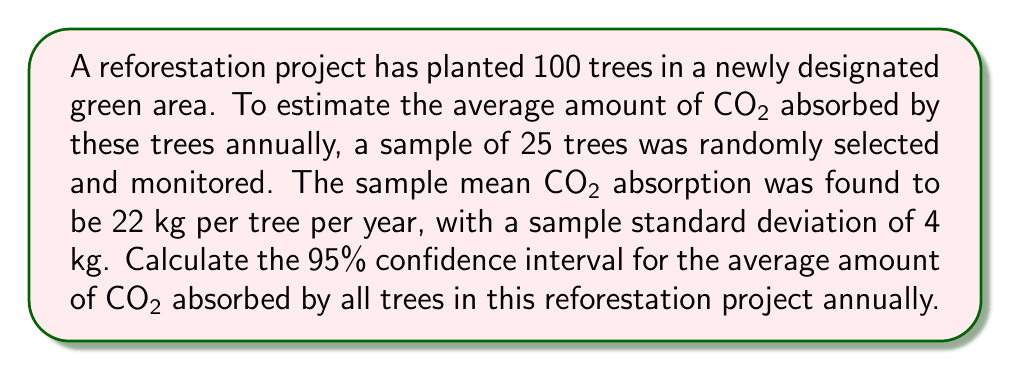Show me your answer to this math problem. To calculate the 95% confidence interval, we'll follow these steps:

1. Identify the given information:
   - Sample size (n) = 25
   - Sample mean (x̄) = 22 kg
   - Sample standard deviation (s) = 4 kg
   - Confidence level = 95%

2. Determine the critical value (t-score) for a 95% confidence level with 24 degrees of freedom (n-1):
   t₀.₀₂₅,₂₄ ≈ 2.064 (from t-distribution table)

3. Calculate the standard error (SE) of the mean:
   $$ SE = \frac{s}{\sqrt{n}} = \frac{4}{\sqrt{25}} = \frac{4}{5} = 0.8 $$

4. Compute the margin of error (ME):
   $$ ME = t₀.₀₂₅,₂₄ \times SE = 2.064 \times 0.8 = 1.6512 $$

5. Calculate the confidence interval:
   Lower bound: $$ 22 - 1.6512 = 20.3488 $$
   Upper bound: $$ 22 + 1.6512 = 23.6512 $$

Therefore, the 95% confidence interval for the average amount of CO2 absorbed by all trees in this reforestation project annually is (20.3488 kg, 23.6512 kg).
Answer: (20.3488 kg, 23.6512 kg) 